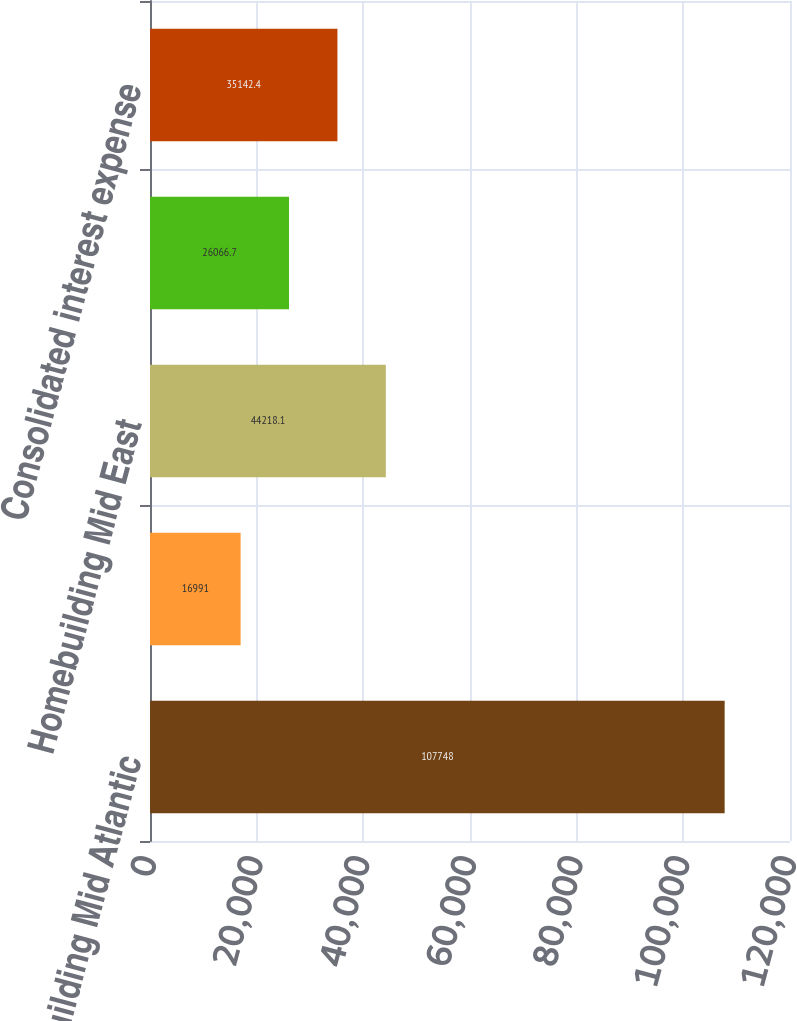<chart> <loc_0><loc_0><loc_500><loc_500><bar_chart><fcel>Homebuilding Mid Atlantic<fcel>Homebuilding North East<fcel>Homebuilding Mid East<fcel>Senior Notes and other<fcel>Consolidated interest expense<nl><fcel>107748<fcel>16991<fcel>44218.1<fcel>26066.7<fcel>35142.4<nl></chart> 